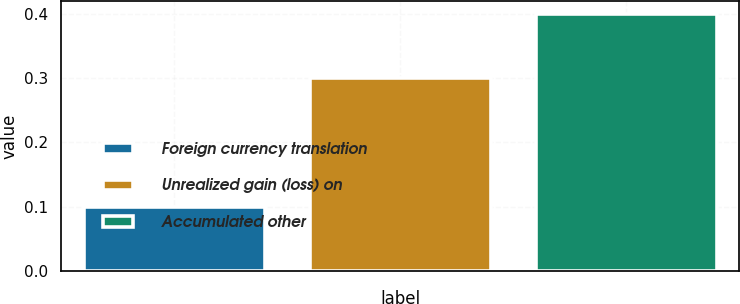<chart> <loc_0><loc_0><loc_500><loc_500><bar_chart><fcel>Foreign currency translation<fcel>Unrealized gain (loss) on<fcel>Accumulated other<nl><fcel>0.1<fcel>0.3<fcel>0.4<nl></chart> 